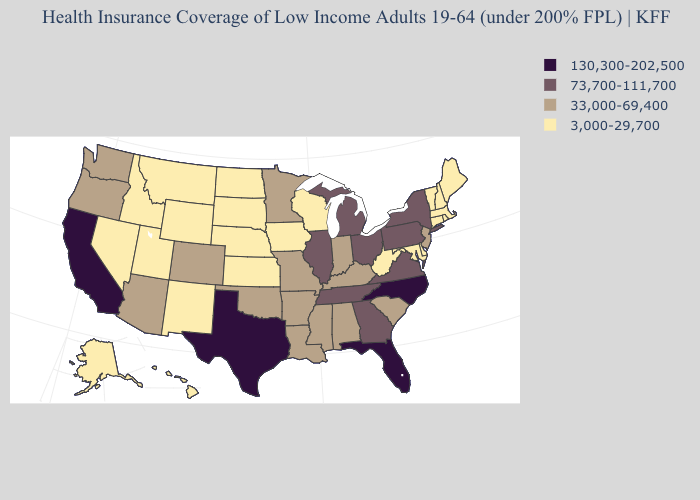What is the highest value in states that border Wyoming?
Answer briefly. 33,000-69,400. What is the value of Kentucky?
Answer briefly. 33,000-69,400. Does Michigan have a higher value than Georgia?
Be succinct. No. What is the value of Arizona?
Concise answer only. 33,000-69,400. What is the highest value in states that border Pennsylvania?
Keep it brief. 73,700-111,700. Does Minnesota have a lower value than Utah?
Quick response, please. No. What is the value of New Mexico?
Short answer required. 3,000-29,700. Name the states that have a value in the range 3,000-29,700?
Concise answer only. Alaska, Connecticut, Delaware, Hawaii, Idaho, Iowa, Kansas, Maine, Maryland, Massachusetts, Montana, Nebraska, Nevada, New Hampshire, New Mexico, North Dakota, Rhode Island, South Dakota, Utah, Vermont, West Virginia, Wisconsin, Wyoming. Does Tennessee have a lower value than Florida?
Concise answer only. Yes. Among the states that border Nebraska , does South Dakota have the highest value?
Write a very short answer. No. What is the highest value in the West ?
Give a very brief answer. 130,300-202,500. Does Indiana have the highest value in the USA?
Concise answer only. No. What is the value of New Jersey?
Give a very brief answer. 33,000-69,400. Does New Jersey have the highest value in the Northeast?
Answer briefly. No. 